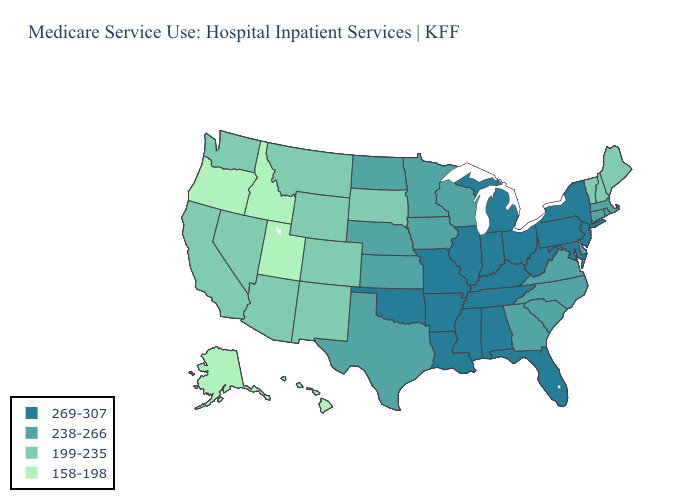Which states have the highest value in the USA?
Be succinct. Alabama, Arkansas, Florida, Illinois, Indiana, Kentucky, Louisiana, Maryland, Michigan, Mississippi, Missouri, New Jersey, New York, Ohio, Oklahoma, Pennsylvania, Tennessee, West Virginia. Does Idaho have the lowest value in the USA?
Answer briefly. Yes. Name the states that have a value in the range 269-307?
Concise answer only. Alabama, Arkansas, Florida, Illinois, Indiana, Kentucky, Louisiana, Maryland, Michigan, Mississippi, Missouri, New Jersey, New York, Ohio, Oklahoma, Pennsylvania, Tennessee, West Virginia. Name the states that have a value in the range 269-307?
Concise answer only. Alabama, Arkansas, Florida, Illinois, Indiana, Kentucky, Louisiana, Maryland, Michigan, Mississippi, Missouri, New Jersey, New York, Ohio, Oklahoma, Pennsylvania, Tennessee, West Virginia. Among the states that border Massachusetts , which have the highest value?
Concise answer only. New York. Name the states that have a value in the range 158-198?
Keep it brief. Alaska, Hawaii, Idaho, Oregon, Utah. Name the states that have a value in the range 269-307?
Give a very brief answer. Alabama, Arkansas, Florida, Illinois, Indiana, Kentucky, Louisiana, Maryland, Michigan, Mississippi, Missouri, New Jersey, New York, Ohio, Oklahoma, Pennsylvania, Tennessee, West Virginia. What is the value of Louisiana?
Be succinct. 269-307. Name the states that have a value in the range 199-235?
Write a very short answer. Arizona, California, Colorado, Maine, Montana, Nevada, New Hampshire, New Mexico, South Dakota, Vermont, Washington, Wyoming. What is the value of Kentucky?
Keep it brief. 269-307. Name the states that have a value in the range 269-307?
Write a very short answer. Alabama, Arkansas, Florida, Illinois, Indiana, Kentucky, Louisiana, Maryland, Michigan, Mississippi, Missouri, New Jersey, New York, Ohio, Oklahoma, Pennsylvania, Tennessee, West Virginia. Name the states that have a value in the range 199-235?
Concise answer only. Arizona, California, Colorado, Maine, Montana, Nevada, New Hampshire, New Mexico, South Dakota, Vermont, Washington, Wyoming. What is the highest value in states that border New Jersey?
Give a very brief answer. 269-307. 